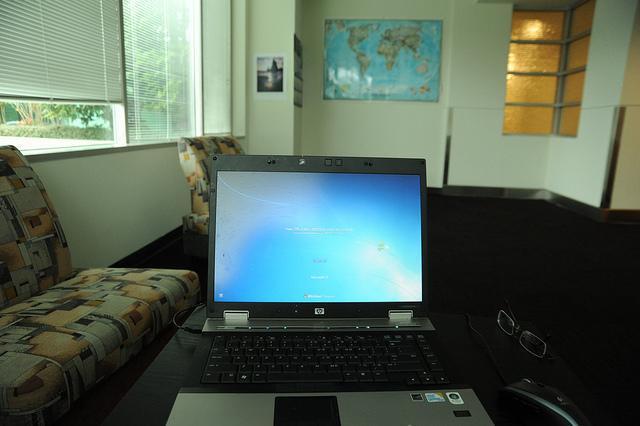How many chairs are there?
Give a very brief answer. 2. How many couches can be seen?
Give a very brief answer. 1. 